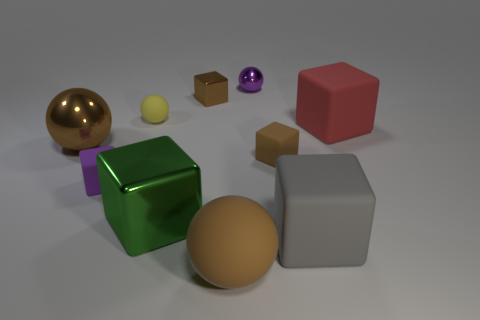Subtract all big gray cubes. How many cubes are left? 5 Subtract all purple spheres. How many spheres are left? 3 Subtract all spheres. How many objects are left? 6 Subtract 1 blocks. How many blocks are left? 5 Add 6 tiny matte objects. How many tiny matte objects are left? 9 Add 6 brown objects. How many brown objects exist? 10 Subtract 0 blue spheres. How many objects are left? 10 Subtract all blue cubes. Subtract all yellow spheres. How many cubes are left? 6 Subtract all cyan cylinders. How many blue balls are left? 0 Subtract all big red matte objects. Subtract all gray rubber objects. How many objects are left? 8 